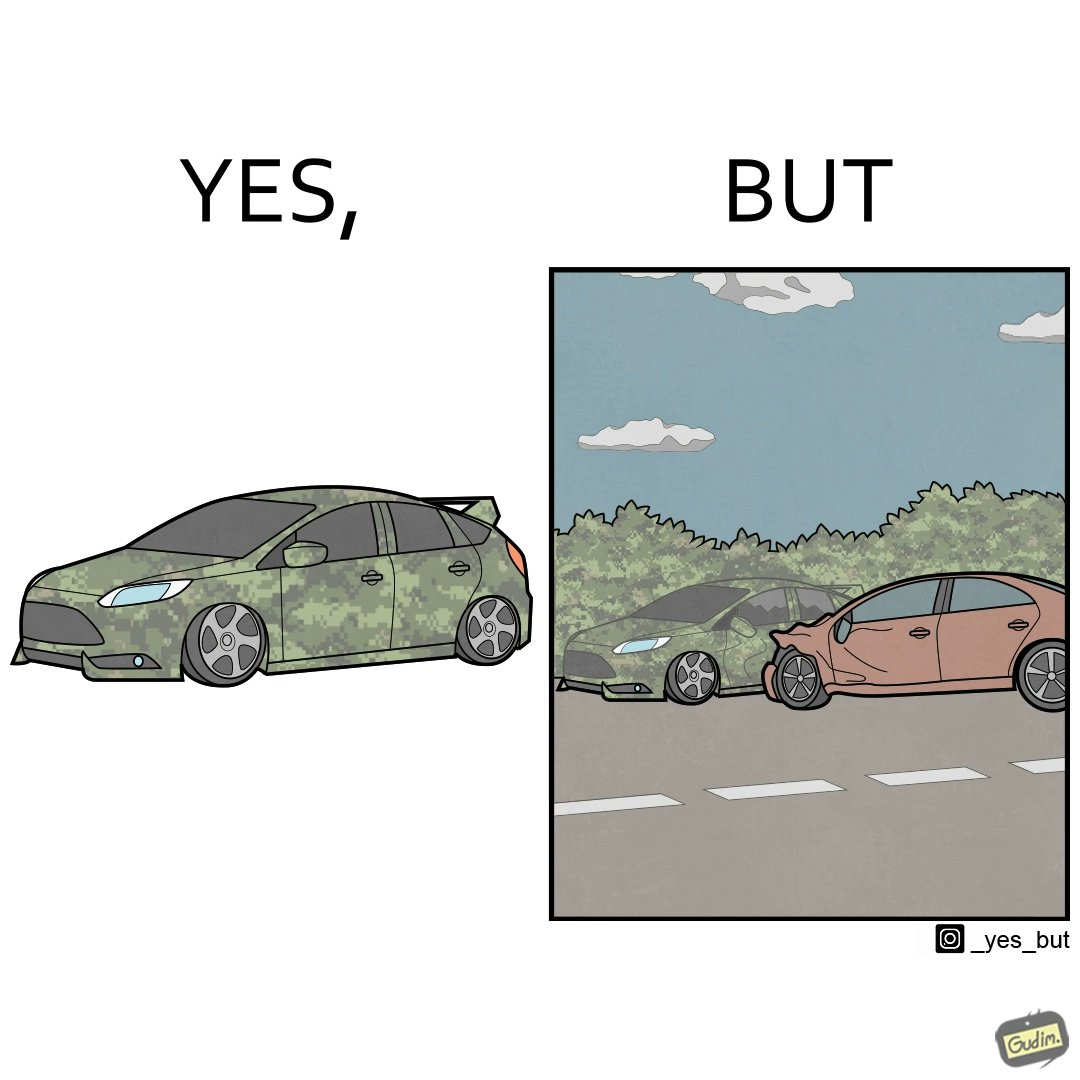Is this a satirical image? Yes, this image is satirical. 